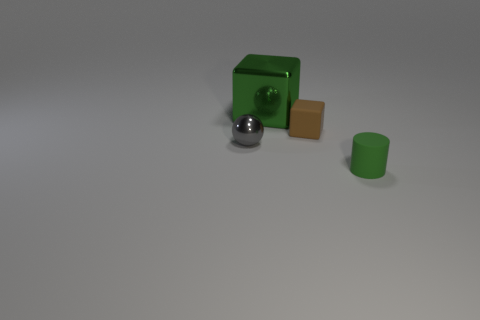Is there any other thing that is the same color as the small matte cylinder?
Offer a very short reply. Yes. Is the shape of the brown object the same as the small green matte thing?
Your answer should be very brief. No. What is the size of the matte thing in front of the tiny rubber thing to the left of the matte object in front of the gray object?
Provide a short and direct response. Small. How many other things are the same material as the large cube?
Offer a terse response. 1. What color is the rubber thing that is behind the tiny rubber cylinder?
Your answer should be compact. Brown. What material is the object to the right of the block that is right of the green object behind the brown object made of?
Provide a short and direct response. Rubber. Are there any tiny rubber objects that have the same shape as the large green object?
Your answer should be compact. Yes. There is a brown matte thing that is the same size as the sphere; what is its shape?
Keep it short and to the point. Cube. How many things are to the left of the tiny green object and to the right of the shiny cube?
Offer a terse response. 1. Are there fewer tiny green matte objects left of the gray sphere than matte things?
Ensure brevity in your answer.  Yes. 